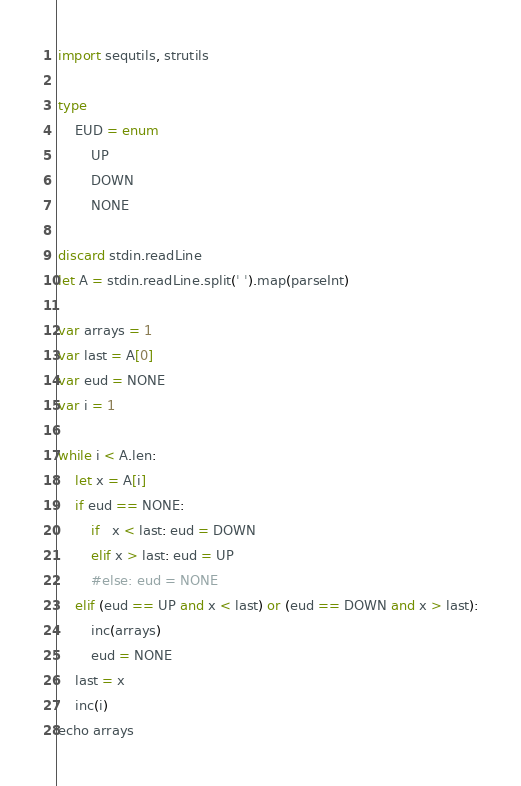<code> <loc_0><loc_0><loc_500><loc_500><_Nim_>import sequtils, strutils

type
    EUD = enum
        UP
        DOWN
        NONE

discard stdin.readLine
let A = stdin.readLine.split(' ').map(parseInt)

var arrays = 1
var last = A[0]
var eud = NONE
var i = 1

while i < A.len:
    let x = A[i]
    if eud == NONE:
        if   x < last: eud = DOWN
        elif x > last: eud = UP
        #else: eud = NONE
    elif (eud == UP and x < last) or (eud == DOWN and x > last):
        inc(arrays)
        eud = NONE
    last = x
    inc(i)
echo arrays
</code> 